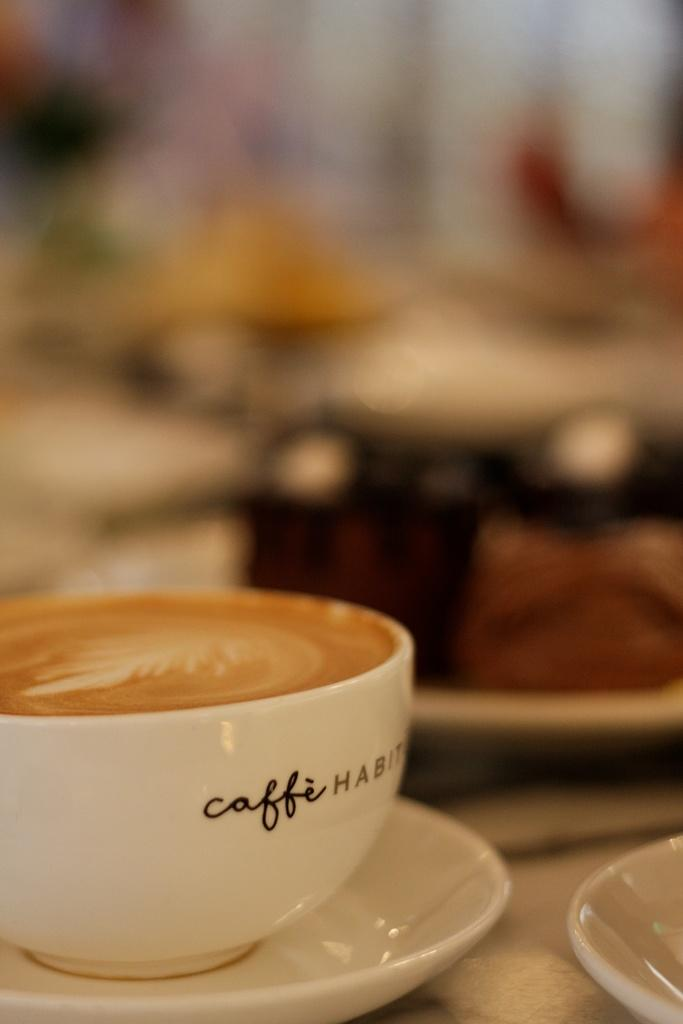What is in the cup that is visible in the image? There is coffee in the cup in the image. How is the cup positioned in relation to the saucer? The cup is placed on a saucer in the image. What is the saucer placed on? The saucer is placed on a surface in the image. Are there any other saucers visible in the image? Yes, there is another saucer in the image. How would you describe the background of the image? The background of the image is blurred. What type of advice can be seen written on the tomatoes in the image? There are no tomatoes present in the image, and therefore no advice can be seen written on them. 